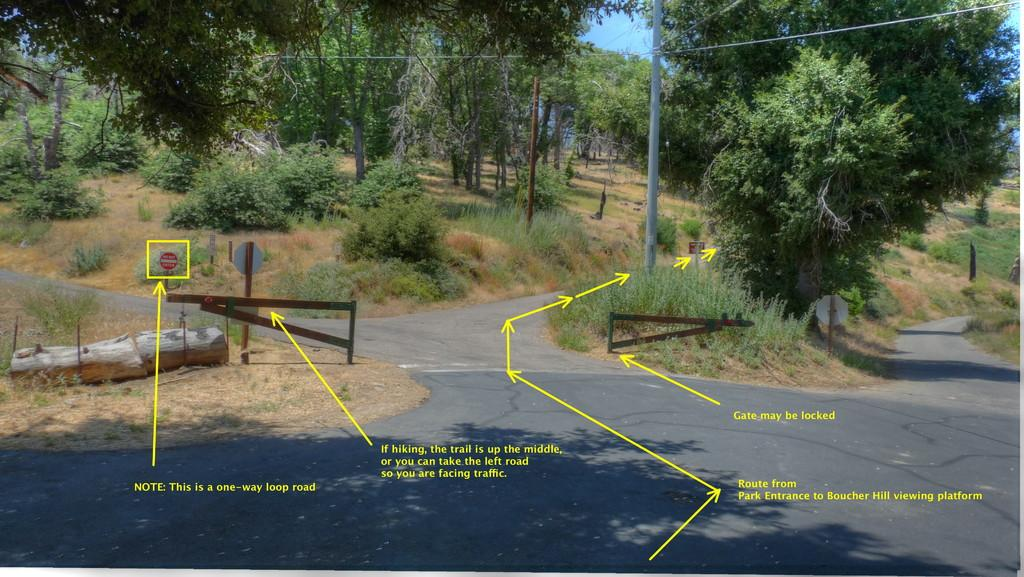What is the main feature of the image? There is a road in the image. What can be found on the road? There is a gate on the road. What other objects are present in the image? There is a log, a pole, sign boards, trees in the background, arrow marks, and some text. Where are the gloves placed in the image? There are no gloves present in the image. Can you see any flowers in the image? There are no flowers visible in the image. 